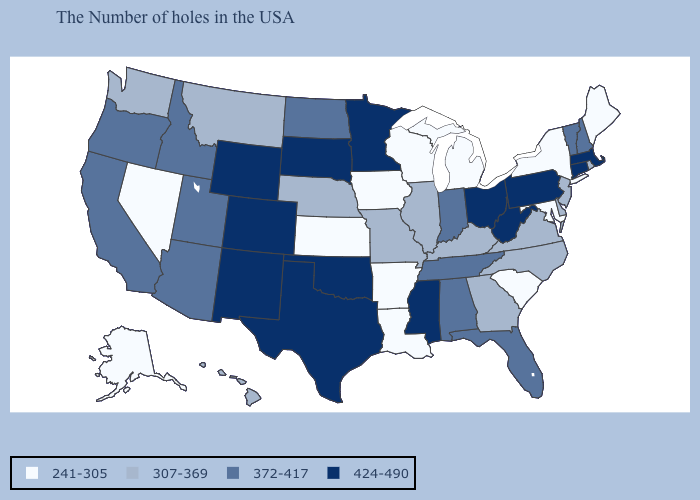Which states hav the highest value in the West?
Concise answer only. Wyoming, Colorado, New Mexico. What is the lowest value in states that border New Mexico?
Answer briefly. 372-417. What is the value of Nevada?
Write a very short answer. 241-305. What is the value of Wisconsin?
Give a very brief answer. 241-305. Does Montana have the highest value in the USA?
Quick response, please. No. Does Indiana have a lower value than Mississippi?
Concise answer only. Yes. What is the lowest value in states that border Mississippi?
Keep it brief. 241-305. Which states have the lowest value in the USA?
Give a very brief answer. Maine, New York, Maryland, South Carolina, Michigan, Wisconsin, Louisiana, Arkansas, Iowa, Kansas, Nevada, Alaska. What is the lowest value in the South?
Short answer required. 241-305. Does Utah have a lower value than South Carolina?
Answer briefly. No. Does Tennessee have the same value as Wyoming?
Concise answer only. No. What is the value of Arkansas?
Keep it brief. 241-305. Name the states that have a value in the range 241-305?
Quick response, please. Maine, New York, Maryland, South Carolina, Michigan, Wisconsin, Louisiana, Arkansas, Iowa, Kansas, Nevada, Alaska. Name the states that have a value in the range 424-490?
Be succinct. Massachusetts, Connecticut, Pennsylvania, West Virginia, Ohio, Mississippi, Minnesota, Oklahoma, Texas, South Dakota, Wyoming, Colorado, New Mexico. Name the states that have a value in the range 307-369?
Write a very short answer. Rhode Island, New Jersey, Delaware, Virginia, North Carolina, Georgia, Kentucky, Illinois, Missouri, Nebraska, Montana, Washington, Hawaii. 